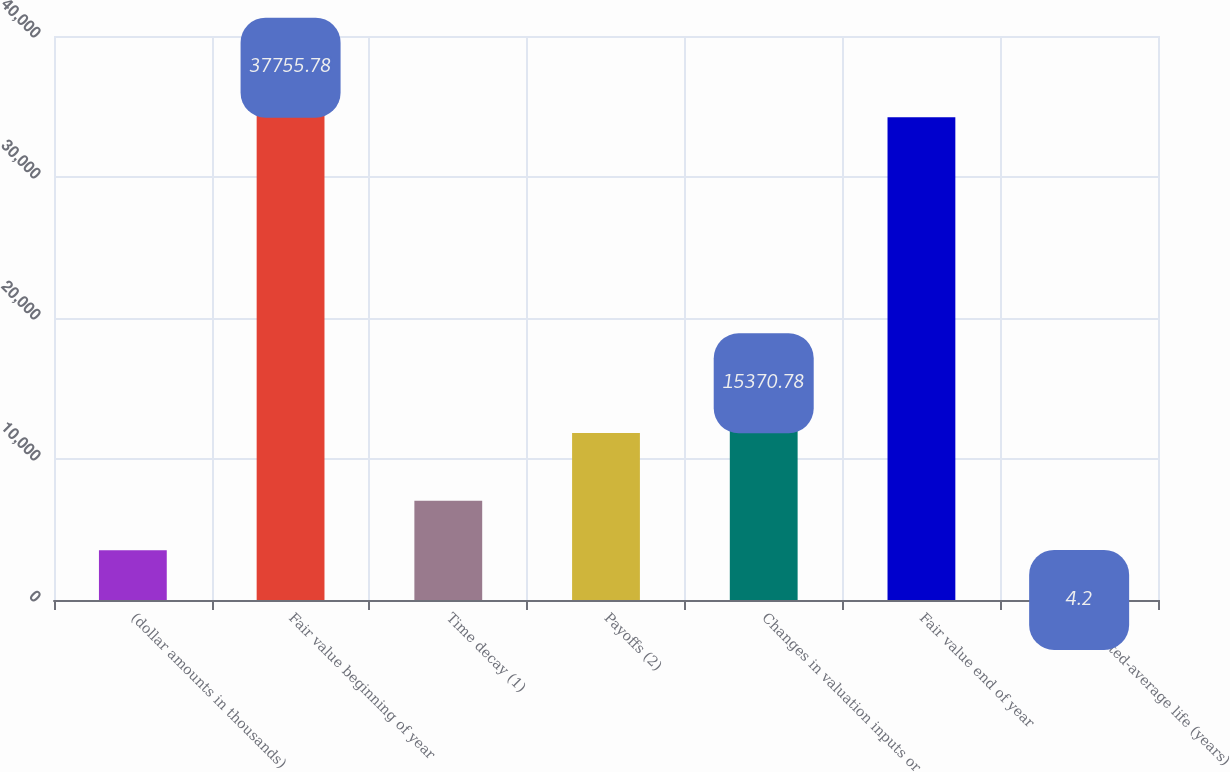<chart> <loc_0><loc_0><loc_500><loc_500><bar_chart><fcel>(dollar amounts in thousands)<fcel>Fair value beginning of year<fcel>Time decay (1)<fcel>Payoffs (2)<fcel>Changes in valuation inputs or<fcel>Fair value end of year<fcel>Weighted-average life (years)<nl><fcel>3523.98<fcel>37755.8<fcel>7043.76<fcel>11851<fcel>15370.8<fcel>34236<fcel>4.2<nl></chart> 